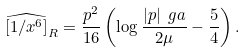Convert formula to latex. <formula><loc_0><loc_0><loc_500><loc_500>\widehat { [ 1 / x ^ { 6 } ] } _ { R } = \frac { p ^ { 2 } } { 1 6 } \left ( \log \frac { | p | \ g a } { 2 \mu } - \frac { 5 } { 4 } \right ) .</formula> 